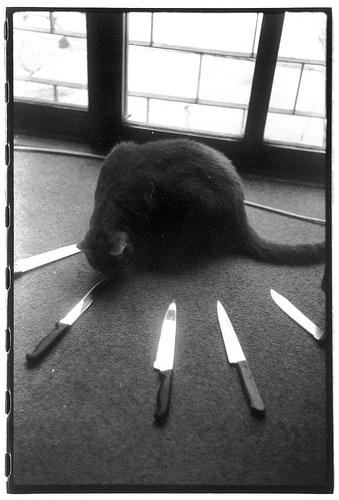What is the cat near?

Choices:
A) knives
B) spoons
C) boxes
D) apples knives 